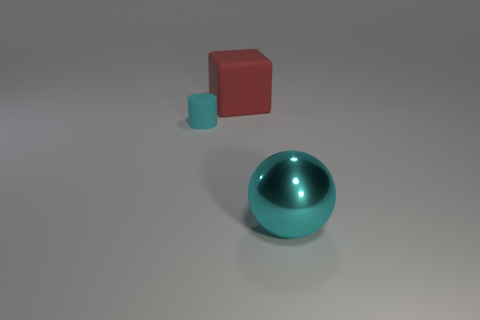Add 2 balls. How many objects exist? 5 Subtract all spheres. How many objects are left? 2 Subtract 1 blocks. How many blocks are left? 0 Subtract all yellow spheres. Subtract all blue cylinders. How many spheres are left? 1 Subtract all big red objects. Subtract all shiny objects. How many objects are left? 1 Add 1 red matte blocks. How many red matte blocks are left? 2 Add 1 tiny things. How many tiny things exist? 2 Subtract 0 yellow blocks. How many objects are left? 3 